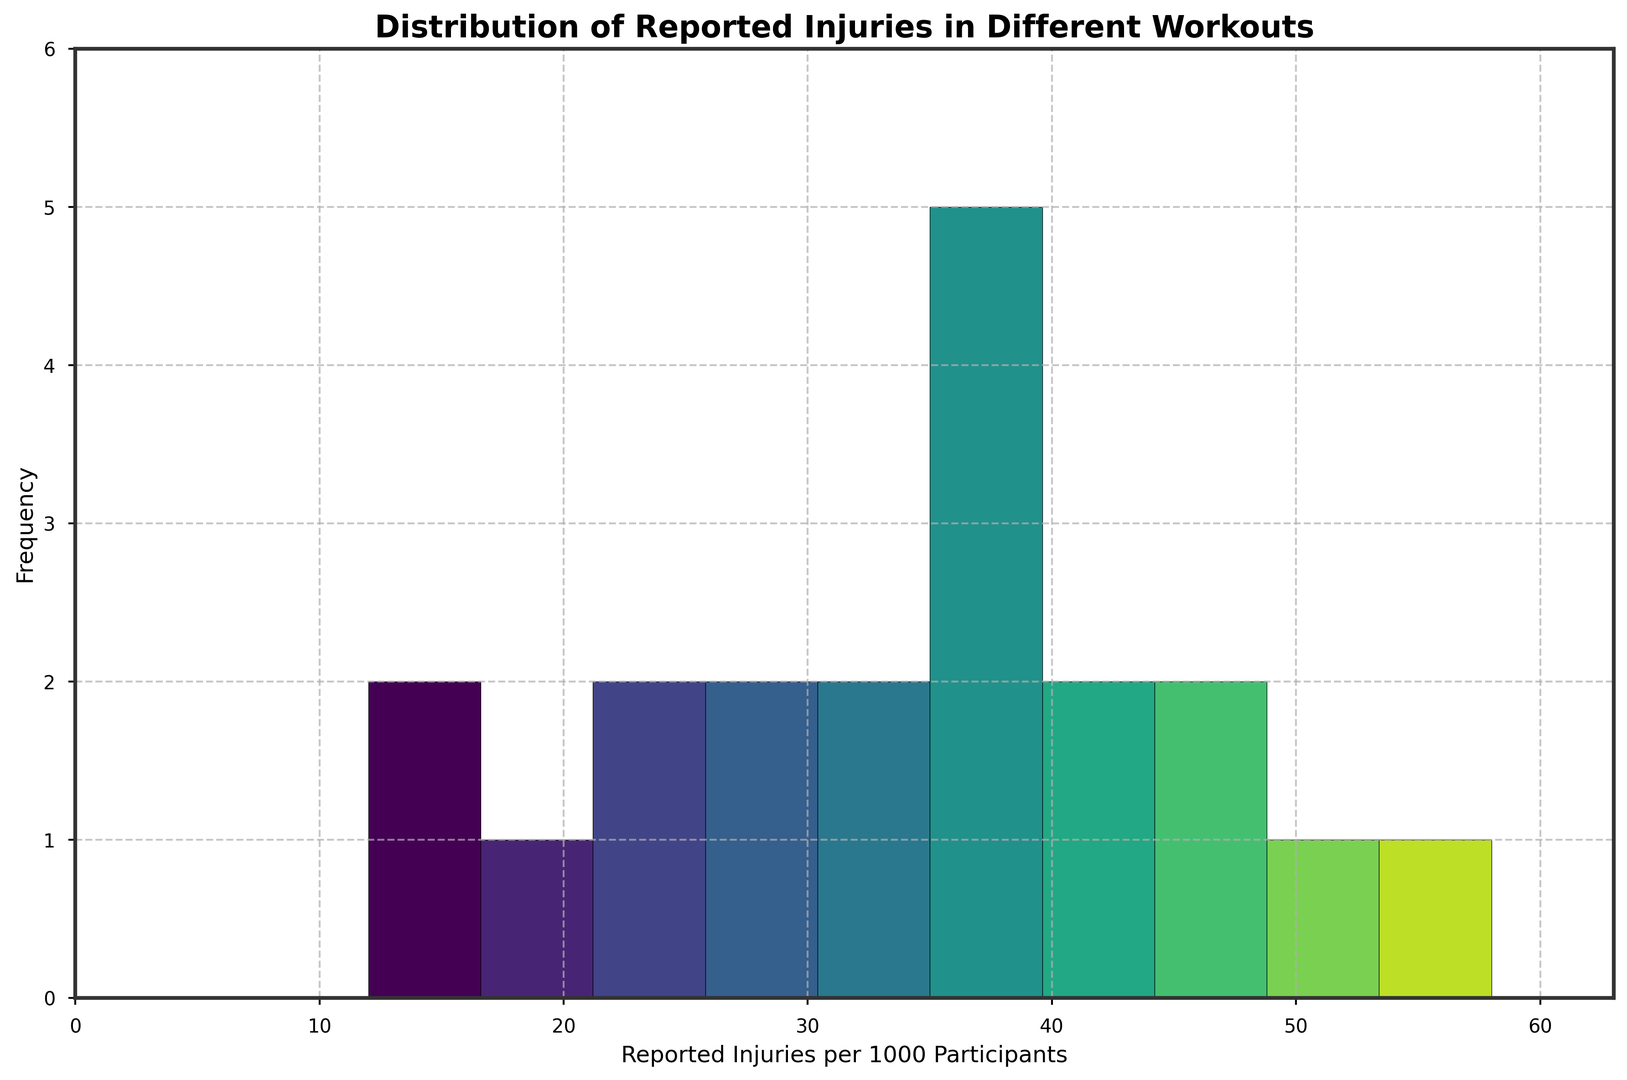How many workouts have reported injuries in the range of 40 to 50 per 1000 participants? Count the number of bars in the histogram that fall within the range of 40 to 50 reported injuries per 1000 participants.
Answer: 5 What is the most common range of reported injuries? Identify the bar with the maximum height in the histogram to determine the range it represents.
Answer: 10-20 per 1000 participants Which workout has the highest frequency of reported injuries? Look at the tallest bar in the histogram and the corresponding range of reported injuries, then refer to the data to find the specific workout(s) in that range.
Answer: CrossFit Are there more workouts with less than 30 reported injuries per 1000 participants or more than 30? Count the number of bars for reported injuries less than 30 and compare it with the number of bars for reported injuries greater than 30 in the histogram.
Answer: More than 30 What is the average number of reported injuries per 1000 participants across all workouts? Sum all the reported injuries and divide by the number of workout types: (32+45+28+52+15+18+58+12+39+35+41+29+37+48+25+22+43+38+33+36) / 20 = 740 / 20
Answer: 37 Which color represents the bar for the range with the highest frequency of injuries? Identify the color of the bar with the maximum height in the histogram.
Answer: First color in the viridis colormap How many workouts have a frequency of reported injuries greater than 45 per 1000 participants? Identify the bars in the histogram that represent greater than 45 reported injuries per 1000 participants and count them.
Answer: 4 What is the median value of the reported injuries per 1000 participants? Organize the data points in ascending order and find the middle value(s). Since there are 20 data points, the median will be the average of the 10th and 11th values: (32+45+28+52+15+18+58+12+39+35+41+29+37+48+25+22+43+38+33+36), sorted: [12, 15, 18, 22, 25, 28, 29, 32, 33, 35, 36, 37, 38, 39, 41, 43, 45, 48, 52, 58], median = (35+36) / 2
Answer: 35.5 Is the frequency of reported injuries for soccer higher than running? Compare the reported injuries per 1000 participants for soccer and running from the data.
Answer: Yes 